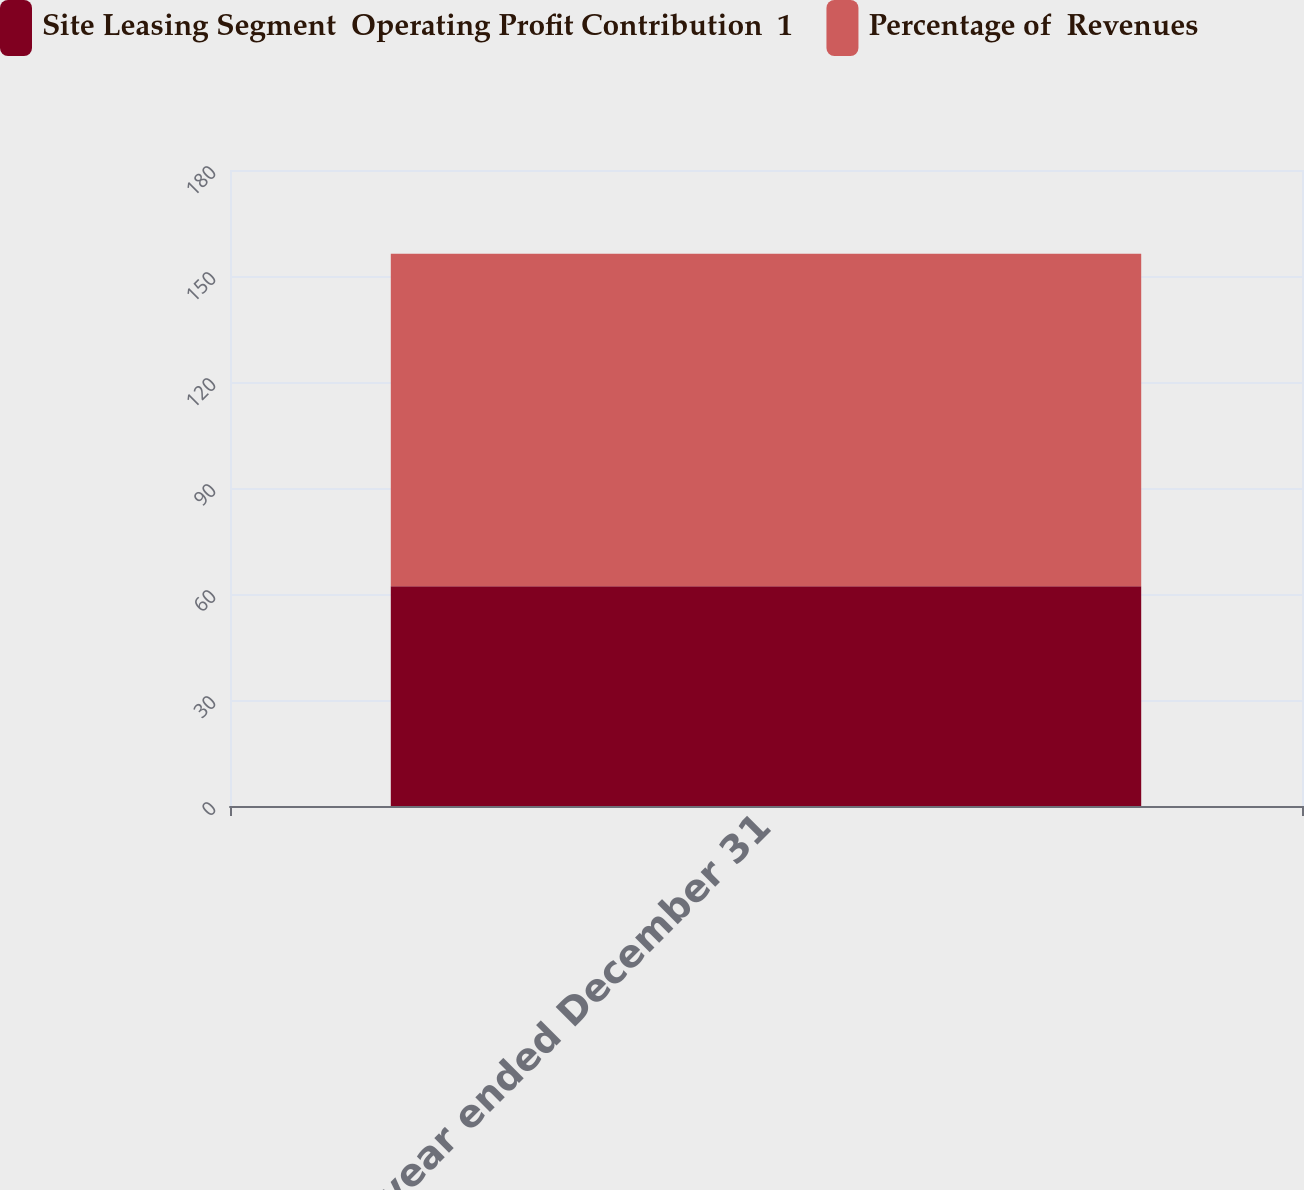Convert chart to OTSL. <chart><loc_0><loc_0><loc_500><loc_500><stacked_bar_chart><ecel><fcel>For the year ended December 31<nl><fcel>Site Leasing Segment  Operating Profit Contribution  1<fcel>62.2<nl><fcel>Percentage of  Revenues<fcel>94.1<nl></chart> 